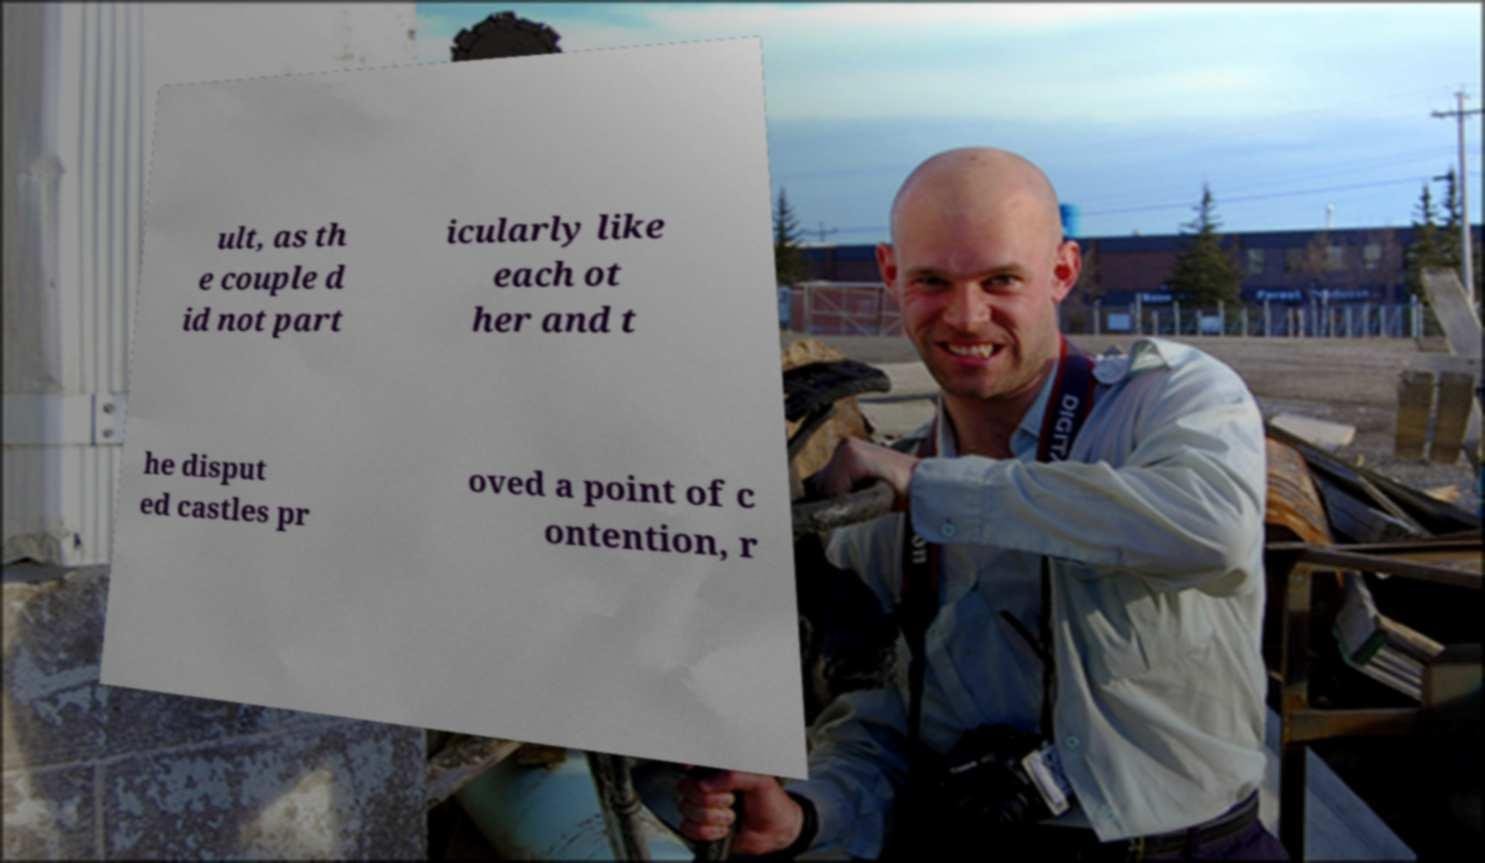Can you read and provide the text displayed in the image?This photo seems to have some interesting text. Can you extract and type it out for me? ult, as th e couple d id not part icularly like each ot her and t he disput ed castles pr oved a point of c ontention, r 